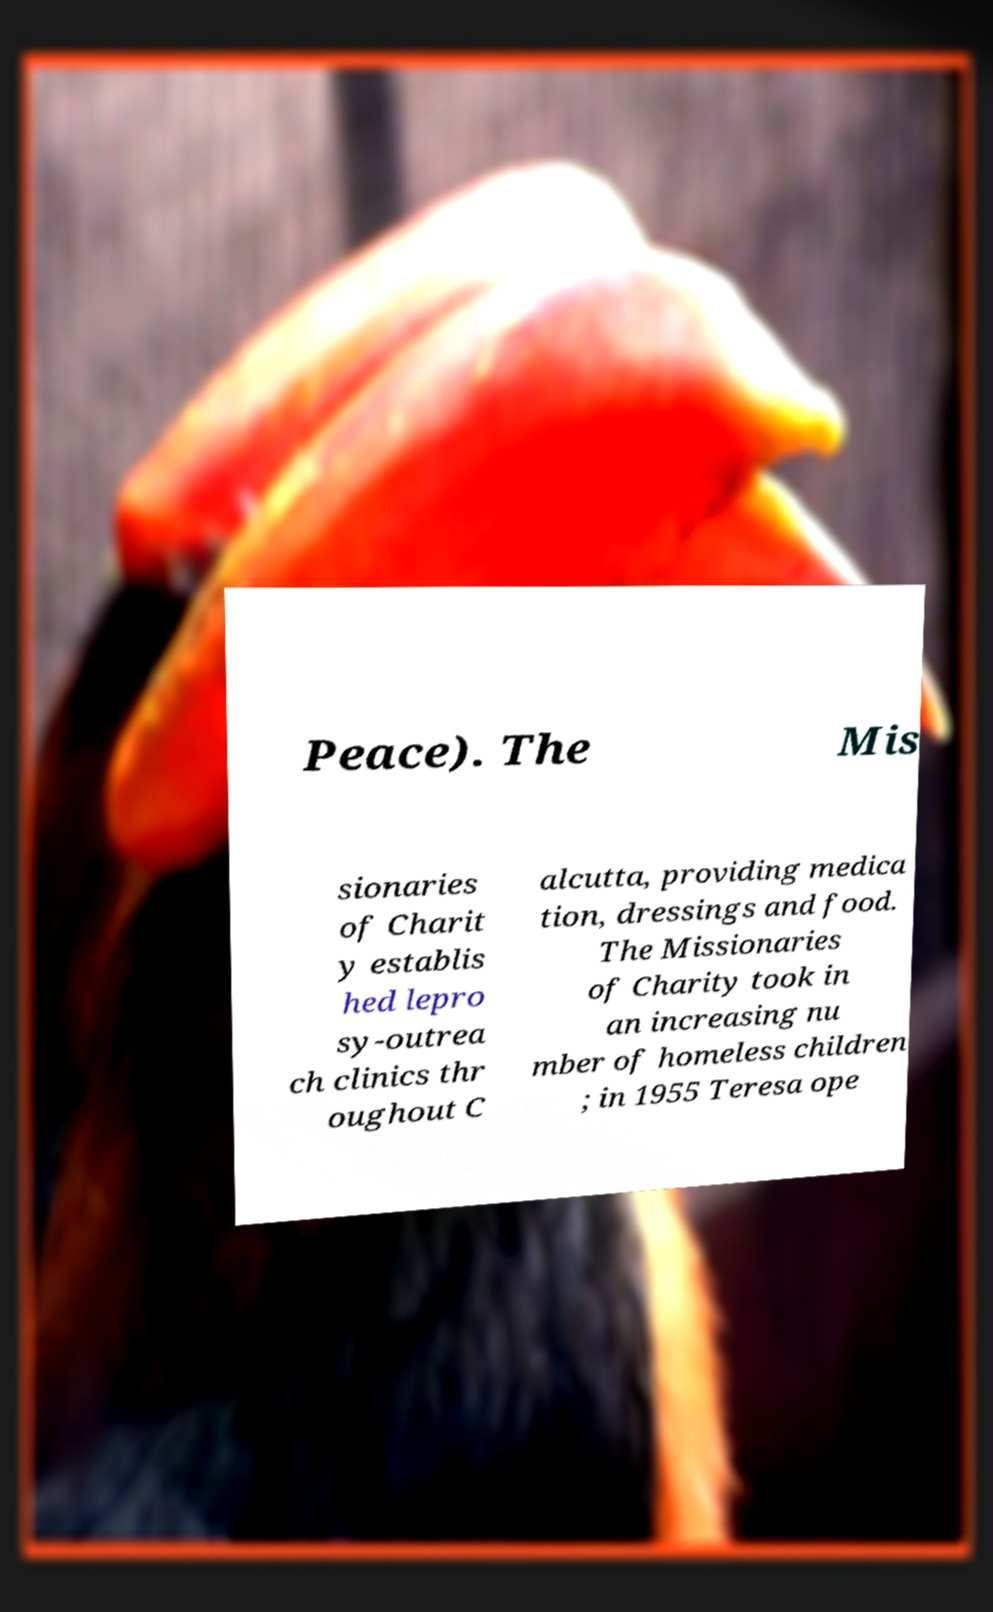Can you read and provide the text displayed in the image?This photo seems to have some interesting text. Can you extract and type it out for me? Peace). The Mis sionaries of Charit y establis hed lepro sy-outrea ch clinics thr oughout C alcutta, providing medica tion, dressings and food. The Missionaries of Charity took in an increasing nu mber of homeless children ; in 1955 Teresa ope 